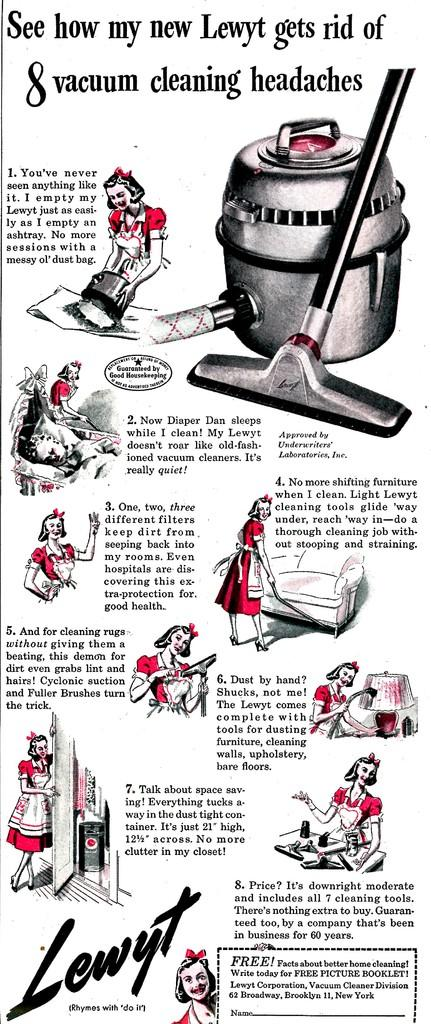<image>
Summarize the visual content of the image. An old infographic extols the benefits of a Lewyt vacuum cleaner. 